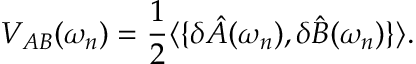<formula> <loc_0><loc_0><loc_500><loc_500>V _ { A B } ( \omega _ { n } ) = \frac { 1 } { 2 } \langle \{ \delta \hat { A } ( \omega _ { n } ) , \delta \hat { B } ( \omega _ { n } ) \} \rangle .</formula> 